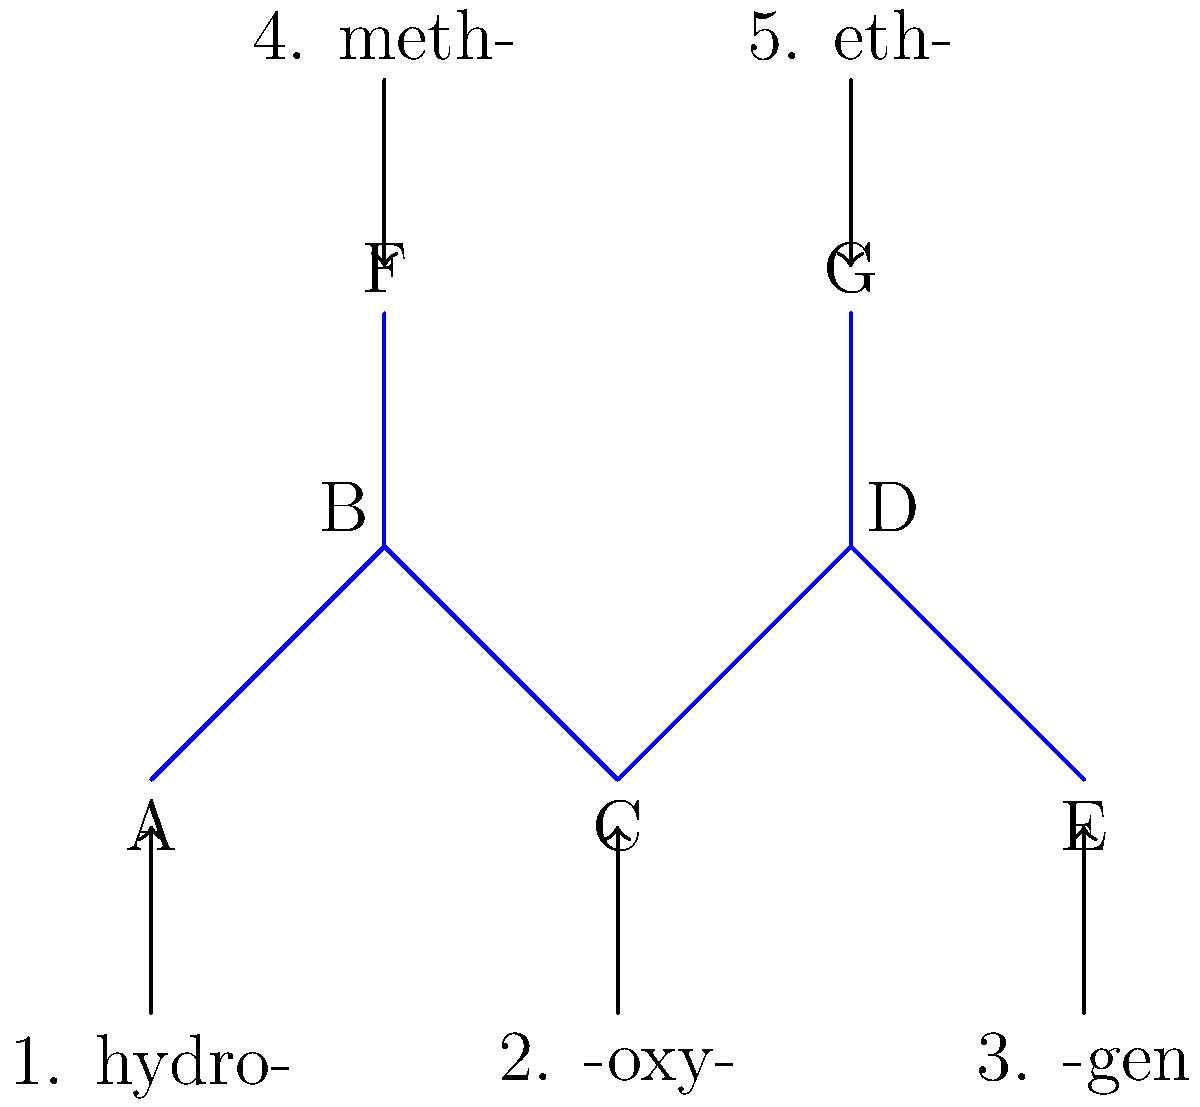Match the etymological components (1-5) to their corresponding parts (A-G) in the molecular structure illustration. Which component corresponds to part C? To solve this problem, we need to analyze the etymological components and their meanings in relation to the molecular structure:

1. hydro-: This prefix relates to hydrogen, typically at the beginning of a molecule.
2. -oxy-: This infix indicates the presence of oxygen, often in the middle of a molecule.
3. -gen: This suffix is often used for elements or groups that produce something.
4. meth-: This prefix is related to methane or single-carbon groups.
5. eth-: This prefix is related to ethane or two-carbon groups.

Now, let's analyze the structure:
- A and E are terminal components, likely hydrogen atoms.
- B and D are junction points with additional bonds (F and G).
- C is in the center of the molecule.
- F and G are single bonds extending from B and D.

Given the central position of C and the meaning of -oxy-, we can deduce that the oxygen component (-oxy-) corresponds to part C in the molecular structure.
Answer: 2. -oxy- 